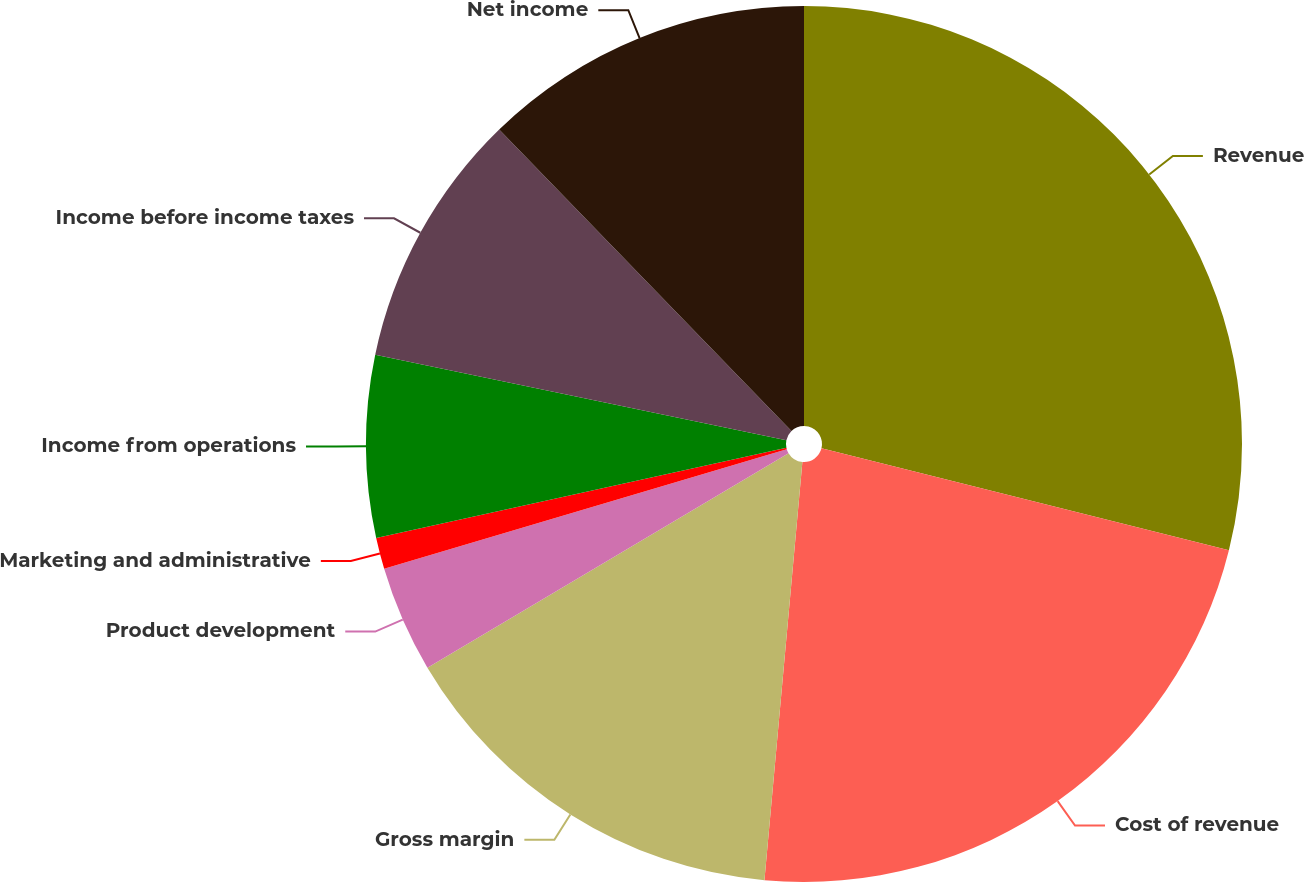Convert chart. <chart><loc_0><loc_0><loc_500><loc_500><pie_chart><fcel>Revenue<fcel>Cost of revenue<fcel>Gross margin<fcel>Product development<fcel>Marketing and administrative<fcel>Income from operations<fcel>Income before income taxes<fcel>Net income<nl><fcel>28.9%<fcel>22.54%<fcel>15.03%<fcel>3.93%<fcel>1.16%<fcel>6.71%<fcel>9.48%<fcel>12.25%<nl></chart> 